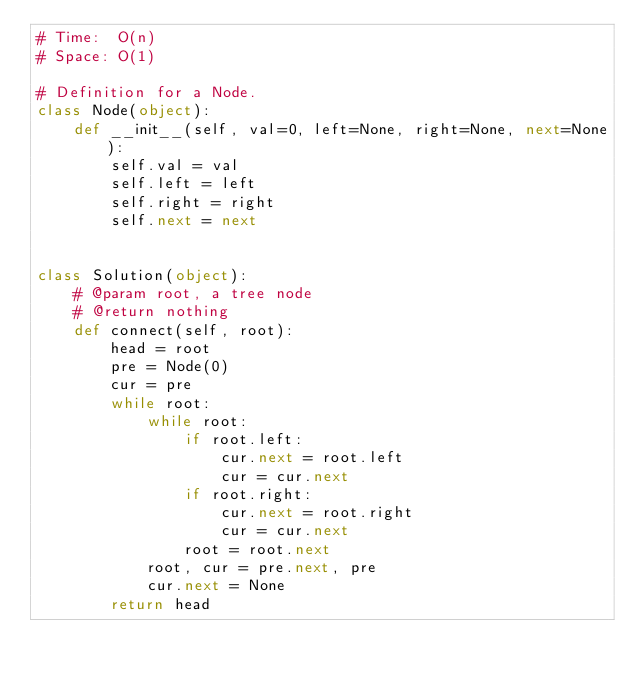Convert code to text. <code><loc_0><loc_0><loc_500><loc_500><_Python_># Time:  O(n)
# Space: O(1)

# Definition for a Node.
class Node(object):
    def __init__(self, val=0, left=None, right=None, next=None):
        self.val = val
        self.left = left
        self.right = right
        self.next = next


class Solution(object):
    # @param root, a tree node
    # @return nothing
    def connect(self, root):
        head = root
        pre = Node(0)
        cur = pre
        while root:
            while root:
                if root.left:
                    cur.next = root.left
                    cur = cur.next
                if root.right:
                    cur.next = root.right
                    cur = cur.next
                root = root.next
            root, cur = pre.next, pre
            cur.next = None
        return head
</code> 